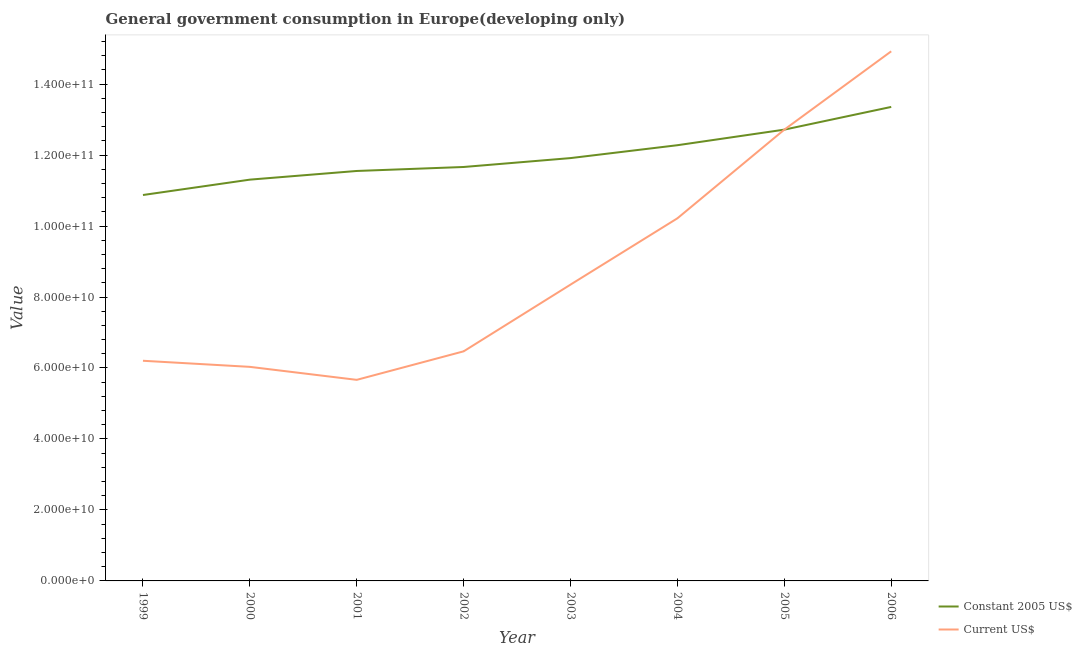Is the number of lines equal to the number of legend labels?
Give a very brief answer. Yes. What is the value consumed in current us$ in 2004?
Make the answer very short. 1.02e+11. Across all years, what is the maximum value consumed in current us$?
Your answer should be very brief. 1.49e+11. Across all years, what is the minimum value consumed in constant 2005 us$?
Give a very brief answer. 1.09e+11. In which year was the value consumed in constant 2005 us$ maximum?
Offer a very short reply. 2006. In which year was the value consumed in constant 2005 us$ minimum?
Provide a succinct answer. 1999. What is the total value consumed in current us$ in the graph?
Your answer should be compact. 7.06e+11. What is the difference between the value consumed in constant 2005 us$ in 1999 and that in 2006?
Your answer should be very brief. -2.48e+1. What is the difference between the value consumed in current us$ in 2005 and the value consumed in constant 2005 us$ in 2001?
Your answer should be very brief. 1.16e+1. What is the average value consumed in current us$ per year?
Keep it short and to the point. 8.82e+1. In the year 2001, what is the difference between the value consumed in constant 2005 us$ and value consumed in current us$?
Ensure brevity in your answer.  5.89e+1. In how many years, is the value consumed in current us$ greater than 32000000000?
Your answer should be very brief. 8. What is the ratio of the value consumed in current us$ in 1999 to that in 2001?
Provide a short and direct response. 1.09. Is the value consumed in constant 2005 us$ in 2000 less than that in 2003?
Keep it short and to the point. Yes. Is the difference between the value consumed in current us$ in 2005 and 2006 greater than the difference between the value consumed in constant 2005 us$ in 2005 and 2006?
Make the answer very short. No. What is the difference between the highest and the second highest value consumed in current us$?
Ensure brevity in your answer.  2.21e+1. What is the difference between the highest and the lowest value consumed in constant 2005 us$?
Give a very brief answer. 2.48e+1. In how many years, is the value consumed in current us$ greater than the average value consumed in current us$ taken over all years?
Make the answer very short. 3. Does the value consumed in current us$ monotonically increase over the years?
Make the answer very short. No. Is the value consumed in current us$ strictly greater than the value consumed in constant 2005 us$ over the years?
Your answer should be compact. No. Is the value consumed in constant 2005 us$ strictly less than the value consumed in current us$ over the years?
Your answer should be very brief. No. How many years are there in the graph?
Your answer should be very brief. 8. What is the difference between two consecutive major ticks on the Y-axis?
Your response must be concise. 2.00e+1. Are the values on the major ticks of Y-axis written in scientific E-notation?
Offer a very short reply. Yes. How many legend labels are there?
Offer a very short reply. 2. How are the legend labels stacked?
Keep it short and to the point. Vertical. What is the title of the graph?
Ensure brevity in your answer.  General government consumption in Europe(developing only). Does "Largest city" appear as one of the legend labels in the graph?
Provide a short and direct response. No. What is the label or title of the X-axis?
Offer a very short reply. Year. What is the label or title of the Y-axis?
Make the answer very short. Value. What is the Value in Constant 2005 US$ in 1999?
Your answer should be very brief. 1.09e+11. What is the Value in Current US$ in 1999?
Ensure brevity in your answer.  6.20e+1. What is the Value of Constant 2005 US$ in 2000?
Your answer should be compact. 1.13e+11. What is the Value of Current US$ in 2000?
Your answer should be very brief. 6.03e+1. What is the Value of Constant 2005 US$ in 2001?
Your answer should be very brief. 1.16e+11. What is the Value in Current US$ in 2001?
Give a very brief answer. 5.67e+1. What is the Value of Constant 2005 US$ in 2002?
Provide a succinct answer. 1.17e+11. What is the Value of Current US$ in 2002?
Your answer should be very brief. 6.47e+1. What is the Value of Constant 2005 US$ in 2003?
Your answer should be very brief. 1.19e+11. What is the Value of Current US$ in 2003?
Your answer should be compact. 8.35e+1. What is the Value of Constant 2005 US$ in 2004?
Give a very brief answer. 1.23e+11. What is the Value in Current US$ in 2004?
Provide a succinct answer. 1.02e+11. What is the Value in Constant 2005 US$ in 2005?
Give a very brief answer. 1.27e+11. What is the Value of Current US$ in 2005?
Give a very brief answer. 1.27e+11. What is the Value of Constant 2005 US$ in 2006?
Your answer should be very brief. 1.34e+11. What is the Value in Current US$ in 2006?
Keep it short and to the point. 1.49e+11. Across all years, what is the maximum Value of Constant 2005 US$?
Provide a short and direct response. 1.34e+11. Across all years, what is the maximum Value of Current US$?
Provide a succinct answer. 1.49e+11. Across all years, what is the minimum Value of Constant 2005 US$?
Offer a very short reply. 1.09e+11. Across all years, what is the minimum Value in Current US$?
Your response must be concise. 5.67e+1. What is the total Value in Constant 2005 US$ in the graph?
Provide a succinct answer. 9.57e+11. What is the total Value of Current US$ in the graph?
Your answer should be very brief. 7.06e+11. What is the difference between the Value of Constant 2005 US$ in 1999 and that in 2000?
Provide a short and direct response. -4.33e+09. What is the difference between the Value in Current US$ in 1999 and that in 2000?
Your answer should be very brief. 1.72e+09. What is the difference between the Value in Constant 2005 US$ in 1999 and that in 2001?
Provide a succinct answer. -6.77e+09. What is the difference between the Value of Current US$ in 1999 and that in 2001?
Your answer should be very brief. 5.38e+09. What is the difference between the Value of Constant 2005 US$ in 1999 and that in 2002?
Provide a short and direct response. -7.90e+09. What is the difference between the Value in Current US$ in 1999 and that in 2002?
Provide a short and direct response. -2.66e+09. What is the difference between the Value in Constant 2005 US$ in 1999 and that in 2003?
Your response must be concise. -1.04e+1. What is the difference between the Value of Current US$ in 1999 and that in 2003?
Ensure brevity in your answer.  -2.15e+1. What is the difference between the Value of Constant 2005 US$ in 1999 and that in 2004?
Offer a terse response. -1.40e+1. What is the difference between the Value of Current US$ in 1999 and that in 2004?
Provide a short and direct response. -4.01e+1. What is the difference between the Value in Constant 2005 US$ in 1999 and that in 2005?
Provide a succinct answer. -1.84e+1. What is the difference between the Value of Current US$ in 1999 and that in 2005?
Make the answer very short. -6.51e+1. What is the difference between the Value in Constant 2005 US$ in 1999 and that in 2006?
Offer a very short reply. -2.48e+1. What is the difference between the Value of Current US$ in 1999 and that in 2006?
Give a very brief answer. -8.72e+1. What is the difference between the Value in Constant 2005 US$ in 2000 and that in 2001?
Your response must be concise. -2.44e+09. What is the difference between the Value in Current US$ in 2000 and that in 2001?
Offer a terse response. 3.66e+09. What is the difference between the Value in Constant 2005 US$ in 2000 and that in 2002?
Provide a succinct answer. -3.57e+09. What is the difference between the Value of Current US$ in 2000 and that in 2002?
Provide a short and direct response. -4.38e+09. What is the difference between the Value in Constant 2005 US$ in 2000 and that in 2003?
Give a very brief answer. -6.07e+09. What is the difference between the Value in Current US$ in 2000 and that in 2003?
Ensure brevity in your answer.  -2.32e+1. What is the difference between the Value in Constant 2005 US$ in 2000 and that in 2004?
Your answer should be compact. -9.70e+09. What is the difference between the Value in Current US$ in 2000 and that in 2004?
Ensure brevity in your answer.  -4.19e+1. What is the difference between the Value of Constant 2005 US$ in 2000 and that in 2005?
Provide a short and direct response. -1.41e+1. What is the difference between the Value of Current US$ in 2000 and that in 2005?
Provide a succinct answer. -6.68e+1. What is the difference between the Value in Constant 2005 US$ in 2000 and that in 2006?
Keep it short and to the point. -2.05e+1. What is the difference between the Value in Current US$ in 2000 and that in 2006?
Provide a short and direct response. -8.89e+1. What is the difference between the Value in Constant 2005 US$ in 2001 and that in 2002?
Make the answer very short. -1.12e+09. What is the difference between the Value of Current US$ in 2001 and that in 2002?
Give a very brief answer. -8.03e+09. What is the difference between the Value in Constant 2005 US$ in 2001 and that in 2003?
Provide a short and direct response. -3.63e+09. What is the difference between the Value in Current US$ in 2001 and that in 2003?
Ensure brevity in your answer.  -2.68e+1. What is the difference between the Value of Constant 2005 US$ in 2001 and that in 2004?
Provide a succinct answer. -7.26e+09. What is the difference between the Value in Current US$ in 2001 and that in 2004?
Your answer should be compact. -4.55e+1. What is the difference between the Value of Constant 2005 US$ in 2001 and that in 2005?
Provide a succinct answer. -1.16e+1. What is the difference between the Value of Current US$ in 2001 and that in 2005?
Offer a terse response. -7.05e+1. What is the difference between the Value of Constant 2005 US$ in 2001 and that in 2006?
Ensure brevity in your answer.  -1.80e+1. What is the difference between the Value in Current US$ in 2001 and that in 2006?
Keep it short and to the point. -9.26e+1. What is the difference between the Value of Constant 2005 US$ in 2002 and that in 2003?
Your answer should be compact. -2.51e+09. What is the difference between the Value in Current US$ in 2002 and that in 2003?
Offer a very short reply. -1.88e+1. What is the difference between the Value in Constant 2005 US$ in 2002 and that in 2004?
Your answer should be very brief. -6.14e+09. What is the difference between the Value in Current US$ in 2002 and that in 2004?
Your response must be concise. -3.75e+1. What is the difference between the Value in Constant 2005 US$ in 2002 and that in 2005?
Provide a succinct answer. -1.05e+1. What is the difference between the Value in Current US$ in 2002 and that in 2005?
Keep it short and to the point. -6.25e+1. What is the difference between the Value in Constant 2005 US$ in 2002 and that in 2006?
Make the answer very short. -1.69e+1. What is the difference between the Value in Current US$ in 2002 and that in 2006?
Provide a succinct answer. -8.45e+1. What is the difference between the Value in Constant 2005 US$ in 2003 and that in 2004?
Your response must be concise. -3.63e+09. What is the difference between the Value of Current US$ in 2003 and that in 2004?
Make the answer very short. -1.87e+1. What is the difference between the Value of Constant 2005 US$ in 2003 and that in 2005?
Your answer should be compact. -8.02e+09. What is the difference between the Value in Current US$ in 2003 and that in 2005?
Provide a short and direct response. -4.37e+1. What is the difference between the Value in Constant 2005 US$ in 2003 and that in 2006?
Provide a short and direct response. -1.44e+1. What is the difference between the Value in Current US$ in 2003 and that in 2006?
Offer a terse response. -6.57e+1. What is the difference between the Value of Constant 2005 US$ in 2004 and that in 2005?
Ensure brevity in your answer.  -4.39e+09. What is the difference between the Value in Current US$ in 2004 and that in 2005?
Make the answer very short. -2.50e+1. What is the difference between the Value in Constant 2005 US$ in 2004 and that in 2006?
Offer a very short reply. -1.08e+1. What is the difference between the Value of Current US$ in 2004 and that in 2006?
Ensure brevity in your answer.  -4.71e+1. What is the difference between the Value of Constant 2005 US$ in 2005 and that in 2006?
Ensure brevity in your answer.  -6.40e+09. What is the difference between the Value of Current US$ in 2005 and that in 2006?
Your response must be concise. -2.21e+1. What is the difference between the Value in Constant 2005 US$ in 1999 and the Value in Current US$ in 2000?
Keep it short and to the point. 4.84e+1. What is the difference between the Value of Constant 2005 US$ in 1999 and the Value of Current US$ in 2001?
Give a very brief answer. 5.21e+1. What is the difference between the Value of Constant 2005 US$ in 1999 and the Value of Current US$ in 2002?
Your response must be concise. 4.40e+1. What is the difference between the Value in Constant 2005 US$ in 1999 and the Value in Current US$ in 2003?
Give a very brief answer. 2.52e+1. What is the difference between the Value of Constant 2005 US$ in 1999 and the Value of Current US$ in 2004?
Make the answer very short. 6.56e+09. What is the difference between the Value in Constant 2005 US$ in 1999 and the Value in Current US$ in 2005?
Offer a very short reply. -1.84e+1. What is the difference between the Value of Constant 2005 US$ in 1999 and the Value of Current US$ in 2006?
Give a very brief answer. -4.05e+1. What is the difference between the Value of Constant 2005 US$ in 2000 and the Value of Current US$ in 2001?
Your answer should be compact. 5.64e+1. What is the difference between the Value in Constant 2005 US$ in 2000 and the Value in Current US$ in 2002?
Provide a succinct answer. 4.84e+1. What is the difference between the Value in Constant 2005 US$ in 2000 and the Value in Current US$ in 2003?
Ensure brevity in your answer.  2.96e+1. What is the difference between the Value of Constant 2005 US$ in 2000 and the Value of Current US$ in 2004?
Ensure brevity in your answer.  1.09e+1. What is the difference between the Value in Constant 2005 US$ in 2000 and the Value in Current US$ in 2005?
Your answer should be compact. -1.41e+1. What is the difference between the Value of Constant 2005 US$ in 2000 and the Value of Current US$ in 2006?
Offer a very short reply. -3.62e+1. What is the difference between the Value in Constant 2005 US$ in 2001 and the Value in Current US$ in 2002?
Keep it short and to the point. 5.08e+1. What is the difference between the Value of Constant 2005 US$ in 2001 and the Value of Current US$ in 2003?
Offer a very short reply. 3.20e+1. What is the difference between the Value in Constant 2005 US$ in 2001 and the Value in Current US$ in 2004?
Provide a succinct answer. 1.33e+1. What is the difference between the Value in Constant 2005 US$ in 2001 and the Value in Current US$ in 2005?
Ensure brevity in your answer.  -1.16e+1. What is the difference between the Value of Constant 2005 US$ in 2001 and the Value of Current US$ in 2006?
Your answer should be very brief. -3.37e+1. What is the difference between the Value in Constant 2005 US$ in 2002 and the Value in Current US$ in 2003?
Make the answer very short. 3.31e+1. What is the difference between the Value in Constant 2005 US$ in 2002 and the Value in Current US$ in 2004?
Make the answer very short. 1.45e+1. What is the difference between the Value in Constant 2005 US$ in 2002 and the Value in Current US$ in 2005?
Provide a succinct answer. -1.05e+1. What is the difference between the Value in Constant 2005 US$ in 2002 and the Value in Current US$ in 2006?
Your response must be concise. -3.26e+1. What is the difference between the Value of Constant 2005 US$ in 2003 and the Value of Current US$ in 2004?
Provide a succinct answer. 1.70e+1. What is the difference between the Value in Constant 2005 US$ in 2003 and the Value in Current US$ in 2005?
Provide a succinct answer. -8.02e+09. What is the difference between the Value of Constant 2005 US$ in 2003 and the Value of Current US$ in 2006?
Offer a terse response. -3.01e+1. What is the difference between the Value of Constant 2005 US$ in 2004 and the Value of Current US$ in 2005?
Provide a succinct answer. -4.39e+09. What is the difference between the Value in Constant 2005 US$ in 2004 and the Value in Current US$ in 2006?
Make the answer very short. -2.65e+1. What is the difference between the Value of Constant 2005 US$ in 2005 and the Value of Current US$ in 2006?
Provide a succinct answer. -2.21e+1. What is the average Value in Constant 2005 US$ per year?
Make the answer very short. 1.20e+11. What is the average Value of Current US$ per year?
Ensure brevity in your answer.  8.82e+1. In the year 1999, what is the difference between the Value in Constant 2005 US$ and Value in Current US$?
Offer a terse response. 4.67e+1. In the year 2000, what is the difference between the Value of Constant 2005 US$ and Value of Current US$?
Ensure brevity in your answer.  5.28e+1. In the year 2001, what is the difference between the Value in Constant 2005 US$ and Value in Current US$?
Offer a terse response. 5.89e+1. In the year 2002, what is the difference between the Value in Constant 2005 US$ and Value in Current US$?
Offer a very short reply. 5.19e+1. In the year 2003, what is the difference between the Value of Constant 2005 US$ and Value of Current US$?
Ensure brevity in your answer.  3.56e+1. In the year 2004, what is the difference between the Value of Constant 2005 US$ and Value of Current US$?
Ensure brevity in your answer.  2.06e+1. In the year 2006, what is the difference between the Value in Constant 2005 US$ and Value in Current US$?
Offer a very short reply. -1.57e+1. What is the ratio of the Value in Constant 2005 US$ in 1999 to that in 2000?
Your answer should be very brief. 0.96. What is the ratio of the Value in Current US$ in 1999 to that in 2000?
Your answer should be very brief. 1.03. What is the ratio of the Value in Constant 2005 US$ in 1999 to that in 2001?
Provide a short and direct response. 0.94. What is the ratio of the Value in Current US$ in 1999 to that in 2001?
Make the answer very short. 1.09. What is the ratio of the Value of Constant 2005 US$ in 1999 to that in 2002?
Offer a terse response. 0.93. What is the ratio of the Value in Current US$ in 1999 to that in 2002?
Your answer should be very brief. 0.96. What is the ratio of the Value of Constant 2005 US$ in 1999 to that in 2003?
Keep it short and to the point. 0.91. What is the ratio of the Value in Current US$ in 1999 to that in 2003?
Provide a succinct answer. 0.74. What is the ratio of the Value in Constant 2005 US$ in 1999 to that in 2004?
Give a very brief answer. 0.89. What is the ratio of the Value of Current US$ in 1999 to that in 2004?
Your answer should be very brief. 0.61. What is the ratio of the Value of Constant 2005 US$ in 1999 to that in 2005?
Make the answer very short. 0.86. What is the ratio of the Value of Current US$ in 1999 to that in 2005?
Give a very brief answer. 0.49. What is the ratio of the Value of Constant 2005 US$ in 1999 to that in 2006?
Offer a terse response. 0.81. What is the ratio of the Value in Current US$ in 1999 to that in 2006?
Provide a short and direct response. 0.42. What is the ratio of the Value of Constant 2005 US$ in 2000 to that in 2001?
Keep it short and to the point. 0.98. What is the ratio of the Value in Current US$ in 2000 to that in 2001?
Your answer should be compact. 1.06. What is the ratio of the Value in Constant 2005 US$ in 2000 to that in 2002?
Your answer should be compact. 0.97. What is the ratio of the Value of Current US$ in 2000 to that in 2002?
Offer a very short reply. 0.93. What is the ratio of the Value of Constant 2005 US$ in 2000 to that in 2003?
Give a very brief answer. 0.95. What is the ratio of the Value in Current US$ in 2000 to that in 2003?
Offer a very short reply. 0.72. What is the ratio of the Value in Constant 2005 US$ in 2000 to that in 2004?
Make the answer very short. 0.92. What is the ratio of the Value in Current US$ in 2000 to that in 2004?
Your response must be concise. 0.59. What is the ratio of the Value in Constant 2005 US$ in 2000 to that in 2005?
Provide a succinct answer. 0.89. What is the ratio of the Value in Current US$ in 2000 to that in 2005?
Provide a short and direct response. 0.47. What is the ratio of the Value in Constant 2005 US$ in 2000 to that in 2006?
Give a very brief answer. 0.85. What is the ratio of the Value in Current US$ in 2000 to that in 2006?
Your answer should be compact. 0.4. What is the ratio of the Value of Current US$ in 2001 to that in 2002?
Ensure brevity in your answer.  0.88. What is the ratio of the Value of Constant 2005 US$ in 2001 to that in 2003?
Ensure brevity in your answer.  0.97. What is the ratio of the Value of Current US$ in 2001 to that in 2003?
Give a very brief answer. 0.68. What is the ratio of the Value of Constant 2005 US$ in 2001 to that in 2004?
Provide a short and direct response. 0.94. What is the ratio of the Value in Current US$ in 2001 to that in 2004?
Provide a succinct answer. 0.55. What is the ratio of the Value in Constant 2005 US$ in 2001 to that in 2005?
Make the answer very short. 0.91. What is the ratio of the Value in Current US$ in 2001 to that in 2005?
Give a very brief answer. 0.45. What is the ratio of the Value of Constant 2005 US$ in 2001 to that in 2006?
Your response must be concise. 0.86. What is the ratio of the Value of Current US$ in 2001 to that in 2006?
Your response must be concise. 0.38. What is the ratio of the Value in Constant 2005 US$ in 2002 to that in 2003?
Provide a short and direct response. 0.98. What is the ratio of the Value in Current US$ in 2002 to that in 2003?
Offer a terse response. 0.77. What is the ratio of the Value in Constant 2005 US$ in 2002 to that in 2004?
Your answer should be very brief. 0.95. What is the ratio of the Value in Current US$ in 2002 to that in 2004?
Make the answer very short. 0.63. What is the ratio of the Value in Constant 2005 US$ in 2002 to that in 2005?
Give a very brief answer. 0.92. What is the ratio of the Value of Current US$ in 2002 to that in 2005?
Offer a terse response. 0.51. What is the ratio of the Value in Constant 2005 US$ in 2002 to that in 2006?
Your response must be concise. 0.87. What is the ratio of the Value in Current US$ in 2002 to that in 2006?
Offer a very short reply. 0.43. What is the ratio of the Value in Constant 2005 US$ in 2003 to that in 2004?
Your answer should be very brief. 0.97. What is the ratio of the Value in Current US$ in 2003 to that in 2004?
Your answer should be very brief. 0.82. What is the ratio of the Value in Constant 2005 US$ in 2003 to that in 2005?
Offer a terse response. 0.94. What is the ratio of the Value in Current US$ in 2003 to that in 2005?
Your answer should be compact. 0.66. What is the ratio of the Value in Constant 2005 US$ in 2003 to that in 2006?
Your response must be concise. 0.89. What is the ratio of the Value of Current US$ in 2003 to that in 2006?
Give a very brief answer. 0.56. What is the ratio of the Value in Constant 2005 US$ in 2004 to that in 2005?
Give a very brief answer. 0.97. What is the ratio of the Value of Current US$ in 2004 to that in 2005?
Keep it short and to the point. 0.8. What is the ratio of the Value in Constant 2005 US$ in 2004 to that in 2006?
Your answer should be compact. 0.92. What is the ratio of the Value in Current US$ in 2004 to that in 2006?
Provide a short and direct response. 0.68. What is the ratio of the Value of Constant 2005 US$ in 2005 to that in 2006?
Provide a short and direct response. 0.95. What is the ratio of the Value of Current US$ in 2005 to that in 2006?
Provide a short and direct response. 0.85. What is the difference between the highest and the second highest Value in Constant 2005 US$?
Offer a terse response. 6.40e+09. What is the difference between the highest and the second highest Value of Current US$?
Your answer should be compact. 2.21e+1. What is the difference between the highest and the lowest Value in Constant 2005 US$?
Offer a terse response. 2.48e+1. What is the difference between the highest and the lowest Value in Current US$?
Provide a short and direct response. 9.26e+1. 